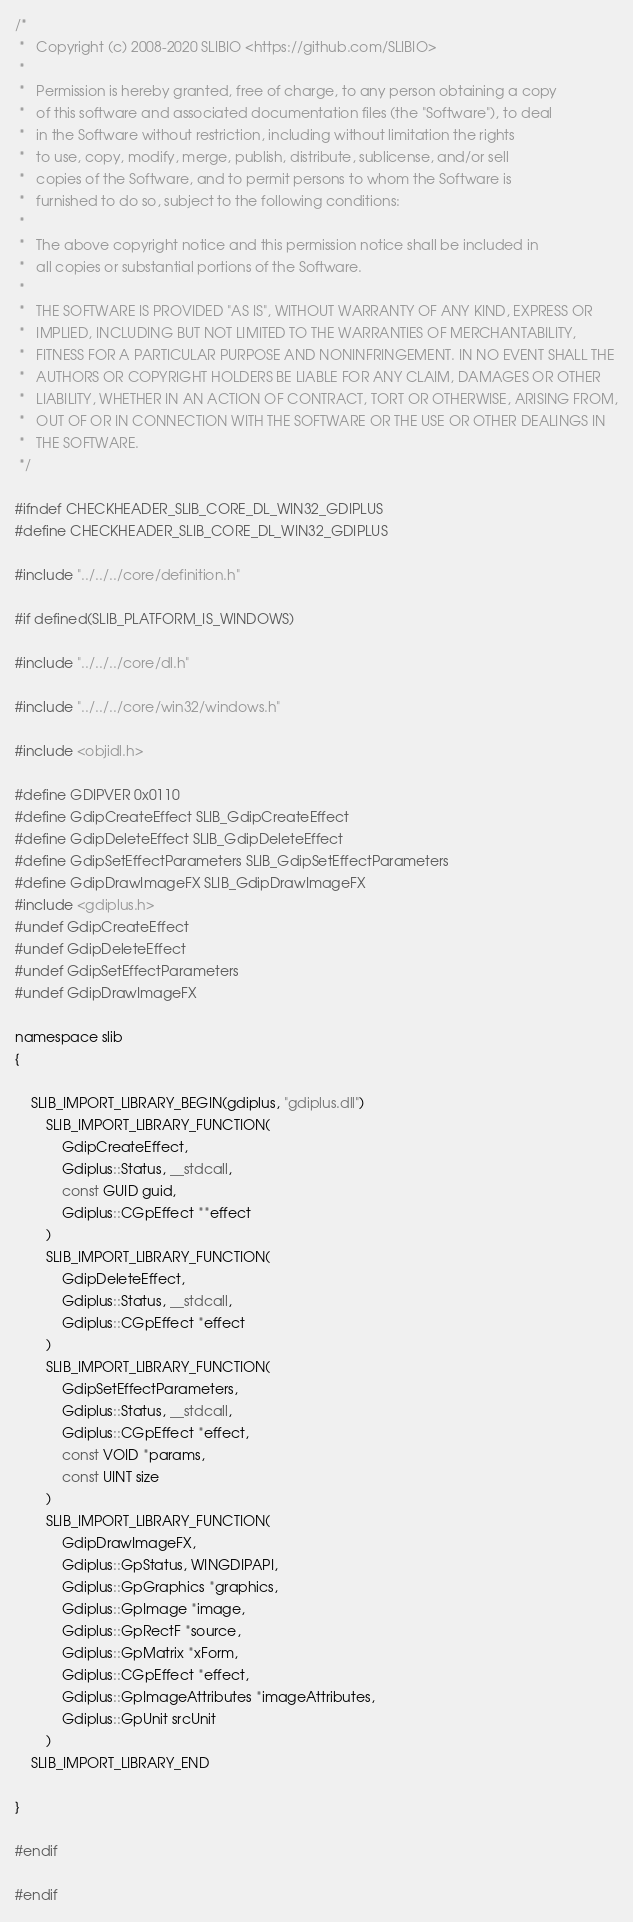<code> <loc_0><loc_0><loc_500><loc_500><_C_>/*
 *   Copyright (c) 2008-2020 SLIBIO <https://github.com/SLIBIO>
 *
 *   Permission is hereby granted, free of charge, to any person obtaining a copy
 *   of this software and associated documentation files (the "Software"), to deal
 *   in the Software without restriction, including without limitation the rights
 *   to use, copy, modify, merge, publish, distribute, sublicense, and/or sell
 *   copies of the Software, and to permit persons to whom the Software is
 *   furnished to do so, subject to the following conditions:
 *
 *   The above copyright notice and this permission notice shall be included in
 *   all copies or substantial portions of the Software.
 *
 *   THE SOFTWARE IS PROVIDED "AS IS", WITHOUT WARRANTY OF ANY KIND, EXPRESS OR
 *   IMPLIED, INCLUDING BUT NOT LIMITED TO THE WARRANTIES OF MERCHANTABILITY,
 *   FITNESS FOR A PARTICULAR PURPOSE AND NONINFRINGEMENT. IN NO EVENT SHALL THE
 *   AUTHORS OR COPYRIGHT HOLDERS BE LIABLE FOR ANY CLAIM, DAMAGES OR OTHER
 *   LIABILITY, WHETHER IN AN ACTION OF CONTRACT, TORT OR OTHERWISE, ARISING FROM,
 *   OUT OF OR IN CONNECTION WITH THE SOFTWARE OR THE USE OR OTHER DEALINGS IN
 *   THE SOFTWARE.
 */

#ifndef CHECKHEADER_SLIB_CORE_DL_WIN32_GDIPLUS
#define CHECKHEADER_SLIB_CORE_DL_WIN32_GDIPLUS

#include "../../../core/definition.h"

#if defined(SLIB_PLATFORM_IS_WINDOWS)

#include "../../../core/dl.h"

#include "../../../core/win32/windows.h"

#include <objidl.h>

#define GDIPVER 0x0110
#define GdipCreateEffect SLIB_GdipCreateEffect
#define GdipDeleteEffect SLIB_GdipDeleteEffect
#define GdipSetEffectParameters SLIB_GdipSetEffectParameters
#define GdipDrawImageFX SLIB_GdipDrawImageFX
#include <gdiplus.h>
#undef GdipCreateEffect
#undef GdipDeleteEffect
#undef GdipSetEffectParameters
#undef GdipDrawImageFX

namespace slib
{

	SLIB_IMPORT_LIBRARY_BEGIN(gdiplus, "gdiplus.dll")
		SLIB_IMPORT_LIBRARY_FUNCTION(
			GdipCreateEffect,
			Gdiplus::Status, __stdcall,
			const GUID guid,
			Gdiplus::CGpEffect **effect
		)
		SLIB_IMPORT_LIBRARY_FUNCTION(
			GdipDeleteEffect,
			Gdiplus::Status, __stdcall,
			Gdiplus::CGpEffect *effect
		)
		SLIB_IMPORT_LIBRARY_FUNCTION(
			GdipSetEffectParameters,
			Gdiplus::Status, __stdcall,
			Gdiplus::CGpEffect *effect,
			const VOID *params,
			const UINT size
		)
		SLIB_IMPORT_LIBRARY_FUNCTION(
			GdipDrawImageFX,
			Gdiplus::GpStatus, WINGDIPAPI,
			Gdiplus::GpGraphics *graphics,
			Gdiplus::GpImage *image,
			Gdiplus::GpRectF *source,
			Gdiplus::GpMatrix *xForm,
			Gdiplus::CGpEffect *effect,
			Gdiplus::GpImageAttributes *imageAttributes,
			Gdiplus::GpUnit srcUnit
		)
	SLIB_IMPORT_LIBRARY_END

}

#endif

#endif
</code> 